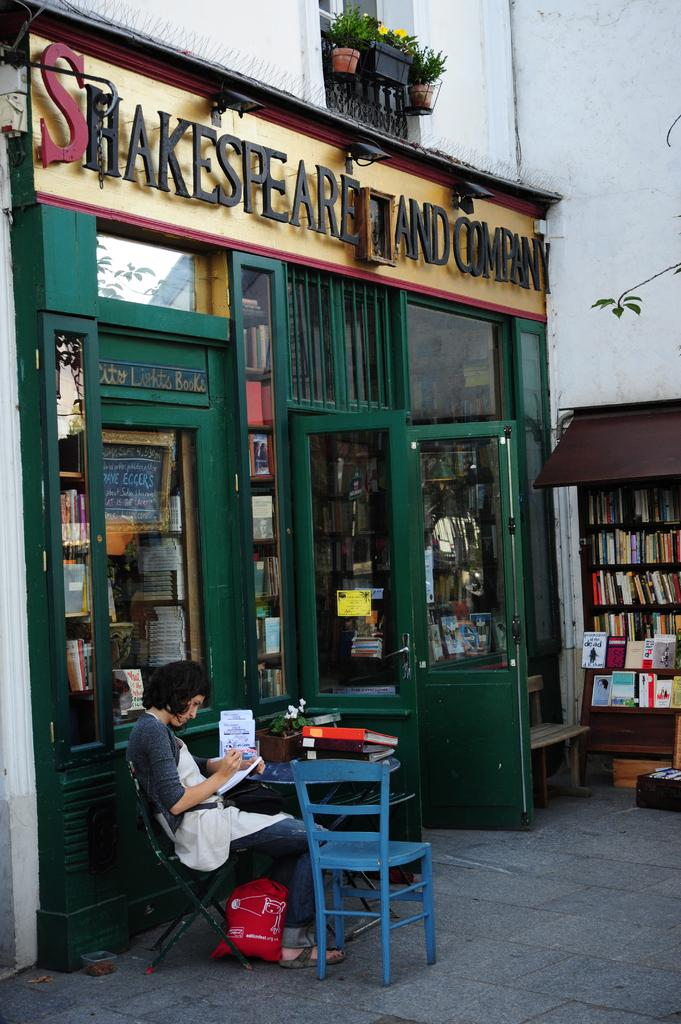What type of establishment is depicted in the image? There is a store in the image. What can be found inside the store? There is a book rack in the store. What is the woman in the image doing? A woman is sitting on a chair in the image. What is in front of the woman? There is a table in front of the woman. What sound is the woman making while sitting on the chair? There is no indication of any sound being made by the woman in the image. 